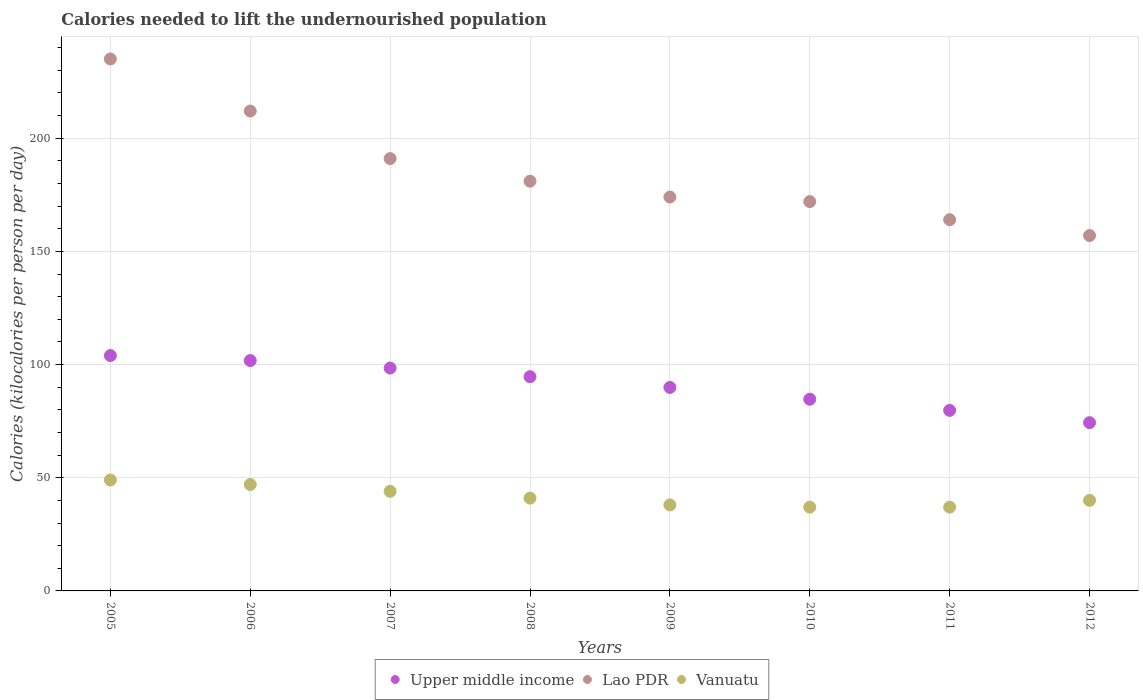How many different coloured dotlines are there?
Offer a terse response. 3. Is the number of dotlines equal to the number of legend labels?
Keep it short and to the point. Yes. What is the total calories needed to lift the undernourished population in Lao PDR in 2007?
Your answer should be compact. 191. Across all years, what is the maximum total calories needed to lift the undernourished population in Lao PDR?
Provide a succinct answer. 235. Across all years, what is the minimum total calories needed to lift the undernourished population in Lao PDR?
Offer a very short reply. 157. In which year was the total calories needed to lift the undernourished population in Vanuatu maximum?
Provide a short and direct response. 2005. What is the total total calories needed to lift the undernourished population in Vanuatu in the graph?
Ensure brevity in your answer.  333. What is the difference between the total calories needed to lift the undernourished population in Vanuatu in 2005 and that in 2007?
Ensure brevity in your answer.  5. What is the difference between the total calories needed to lift the undernourished population in Lao PDR in 2011 and the total calories needed to lift the undernourished population in Vanuatu in 2009?
Your answer should be very brief. 126. What is the average total calories needed to lift the undernourished population in Lao PDR per year?
Provide a succinct answer. 185.75. In the year 2007, what is the difference between the total calories needed to lift the undernourished population in Upper middle income and total calories needed to lift the undernourished population in Lao PDR?
Keep it short and to the point. -92.55. In how many years, is the total calories needed to lift the undernourished population in Upper middle income greater than 80 kilocalories?
Provide a short and direct response. 6. What is the ratio of the total calories needed to lift the undernourished population in Vanuatu in 2006 to that in 2007?
Provide a succinct answer. 1.07. What is the difference between the highest and the second highest total calories needed to lift the undernourished population in Upper middle income?
Give a very brief answer. 2.21. What is the difference between the highest and the lowest total calories needed to lift the undernourished population in Lao PDR?
Offer a very short reply. 78. In how many years, is the total calories needed to lift the undernourished population in Vanuatu greater than the average total calories needed to lift the undernourished population in Vanuatu taken over all years?
Provide a short and direct response. 3. Is it the case that in every year, the sum of the total calories needed to lift the undernourished population in Vanuatu and total calories needed to lift the undernourished population in Lao PDR  is greater than the total calories needed to lift the undernourished population in Upper middle income?
Make the answer very short. Yes. Is the total calories needed to lift the undernourished population in Vanuatu strictly greater than the total calories needed to lift the undernourished population in Upper middle income over the years?
Offer a very short reply. No. Is the total calories needed to lift the undernourished population in Upper middle income strictly less than the total calories needed to lift the undernourished population in Lao PDR over the years?
Make the answer very short. Yes. Does the graph contain grids?
Give a very brief answer. Yes. How many legend labels are there?
Your answer should be very brief. 3. How are the legend labels stacked?
Offer a terse response. Horizontal. What is the title of the graph?
Your answer should be compact. Calories needed to lift the undernourished population. Does "Greece" appear as one of the legend labels in the graph?
Offer a very short reply. No. What is the label or title of the X-axis?
Ensure brevity in your answer.  Years. What is the label or title of the Y-axis?
Ensure brevity in your answer.  Calories (kilocalories per person per day). What is the Calories (kilocalories per person per day) of Upper middle income in 2005?
Offer a terse response. 103.98. What is the Calories (kilocalories per person per day) in Lao PDR in 2005?
Provide a succinct answer. 235. What is the Calories (kilocalories per person per day) of Upper middle income in 2006?
Your answer should be compact. 101.77. What is the Calories (kilocalories per person per day) in Lao PDR in 2006?
Provide a short and direct response. 212. What is the Calories (kilocalories per person per day) of Vanuatu in 2006?
Your response must be concise. 47. What is the Calories (kilocalories per person per day) of Upper middle income in 2007?
Keep it short and to the point. 98.45. What is the Calories (kilocalories per person per day) of Lao PDR in 2007?
Your answer should be compact. 191. What is the Calories (kilocalories per person per day) in Upper middle income in 2008?
Give a very brief answer. 94.65. What is the Calories (kilocalories per person per day) of Lao PDR in 2008?
Make the answer very short. 181. What is the Calories (kilocalories per person per day) in Upper middle income in 2009?
Your response must be concise. 89.9. What is the Calories (kilocalories per person per day) of Lao PDR in 2009?
Give a very brief answer. 174. What is the Calories (kilocalories per person per day) of Upper middle income in 2010?
Your answer should be very brief. 84.69. What is the Calories (kilocalories per person per day) of Lao PDR in 2010?
Make the answer very short. 172. What is the Calories (kilocalories per person per day) in Vanuatu in 2010?
Give a very brief answer. 37. What is the Calories (kilocalories per person per day) in Upper middle income in 2011?
Offer a very short reply. 79.75. What is the Calories (kilocalories per person per day) of Lao PDR in 2011?
Your response must be concise. 164. What is the Calories (kilocalories per person per day) in Upper middle income in 2012?
Provide a short and direct response. 74.34. What is the Calories (kilocalories per person per day) in Lao PDR in 2012?
Make the answer very short. 157. Across all years, what is the maximum Calories (kilocalories per person per day) of Upper middle income?
Your response must be concise. 103.98. Across all years, what is the maximum Calories (kilocalories per person per day) in Lao PDR?
Keep it short and to the point. 235. Across all years, what is the maximum Calories (kilocalories per person per day) in Vanuatu?
Give a very brief answer. 49. Across all years, what is the minimum Calories (kilocalories per person per day) of Upper middle income?
Provide a succinct answer. 74.34. Across all years, what is the minimum Calories (kilocalories per person per day) of Lao PDR?
Make the answer very short. 157. What is the total Calories (kilocalories per person per day) in Upper middle income in the graph?
Give a very brief answer. 727.54. What is the total Calories (kilocalories per person per day) of Lao PDR in the graph?
Keep it short and to the point. 1486. What is the total Calories (kilocalories per person per day) of Vanuatu in the graph?
Your response must be concise. 333. What is the difference between the Calories (kilocalories per person per day) in Upper middle income in 2005 and that in 2006?
Make the answer very short. 2.21. What is the difference between the Calories (kilocalories per person per day) of Vanuatu in 2005 and that in 2006?
Ensure brevity in your answer.  2. What is the difference between the Calories (kilocalories per person per day) in Upper middle income in 2005 and that in 2007?
Your answer should be very brief. 5.53. What is the difference between the Calories (kilocalories per person per day) of Upper middle income in 2005 and that in 2008?
Offer a terse response. 9.33. What is the difference between the Calories (kilocalories per person per day) in Lao PDR in 2005 and that in 2008?
Provide a short and direct response. 54. What is the difference between the Calories (kilocalories per person per day) in Upper middle income in 2005 and that in 2009?
Your answer should be very brief. 14.08. What is the difference between the Calories (kilocalories per person per day) of Vanuatu in 2005 and that in 2009?
Your answer should be compact. 11. What is the difference between the Calories (kilocalories per person per day) in Upper middle income in 2005 and that in 2010?
Offer a terse response. 19.29. What is the difference between the Calories (kilocalories per person per day) in Lao PDR in 2005 and that in 2010?
Your answer should be compact. 63. What is the difference between the Calories (kilocalories per person per day) of Vanuatu in 2005 and that in 2010?
Provide a succinct answer. 12. What is the difference between the Calories (kilocalories per person per day) of Upper middle income in 2005 and that in 2011?
Make the answer very short. 24.23. What is the difference between the Calories (kilocalories per person per day) in Upper middle income in 2005 and that in 2012?
Make the answer very short. 29.64. What is the difference between the Calories (kilocalories per person per day) in Vanuatu in 2005 and that in 2012?
Provide a succinct answer. 9. What is the difference between the Calories (kilocalories per person per day) in Upper middle income in 2006 and that in 2007?
Your answer should be very brief. 3.32. What is the difference between the Calories (kilocalories per person per day) in Vanuatu in 2006 and that in 2007?
Keep it short and to the point. 3. What is the difference between the Calories (kilocalories per person per day) of Upper middle income in 2006 and that in 2008?
Ensure brevity in your answer.  7.12. What is the difference between the Calories (kilocalories per person per day) in Lao PDR in 2006 and that in 2008?
Your answer should be very brief. 31. What is the difference between the Calories (kilocalories per person per day) of Upper middle income in 2006 and that in 2009?
Your answer should be compact. 11.87. What is the difference between the Calories (kilocalories per person per day) of Lao PDR in 2006 and that in 2009?
Your answer should be very brief. 38. What is the difference between the Calories (kilocalories per person per day) in Upper middle income in 2006 and that in 2010?
Your answer should be compact. 17.08. What is the difference between the Calories (kilocalories per person per day) of Upper middle income in 2006 and that in 2011?
Your answer should be very brief. 22.02. What is the difference between the Calories (kilocalories per person per day) in Upper middle income in 2006 and that in 2012?
Ensure brevity in your answer.  27.44. What is the difference between the Calories (kilocalories per person per day) in Lao PDR in 2006 and that in 2012?
Your answer should be very brief. 55. What is the difference between the Calories (kilocalories per person per day) in Upper middle income in 2007 and that in 2008?
Provide a succinct answer. 3.8. What is the difference between the Calories (kilocalories per person per day) in Lao PDR in 2007 and that in 2008?
Provide a short and direct response. 10. What is the difference between the Calories (kilocalories per person per day) of Upper middle income in 2007 and that in 2009?
Ensure brevity in your answer.  8.56. What is the difference between the Calories (kilocalories per person per day) in Lao PDR in 2007 and that in 2009?
Offer a terse response. 17. What is the difference between the Calories (kilocalories per person per day) in Upper middle income in 2007 and that in 2010?
Your answer should be compact. 13.76. What is the difference between the Calories (kilocalories per person per day) in Lao PDR in 2007 and that in 2010?
Your response must be concise. 19. What is the difference between the Calories (kilocalories per person per day) in Upper middle income in 2007 and that in 2011?
Make the answer very short. 18.7. What is the difference between the Calories (kilocalories per person per day) in Vanuatu in 2007 and that in 2011?
Ensure brevity in your answer.  7. What is the difference between the Calories (kilocalories per person per day) in Upper middle income in 2007 and that in 2012?
Give a very brief answer. 24.12. What is the difference between the Calories (kilocalories per person per day) in Lao PDR in 2007 and that in 2012?
Provide a short and direct response. 34. What is the difference between the Calories (kilocalories per person per day) in Upper middle income in 2008 and that in 2009?
Ensure brevity in your answer.  4.75. What is the difference between the Calories (kilocalories per person per day) in Lao PDR in 2008 and that in 2009?
Offer a very short reply. 7. What is the difference between the Calories (kilocalories per person per day) in Vanuatu in 2008 and that in 2009?
Give a very brief answer. 3. What is the difference between the Calories (kilocalories per person per day) of Upper middle income in 2008 and that in 2010?
Give a very brief answer. 9.96. What is the difference between the Calories (kilocalories per person per day) in Upper middle income in 2008 and that in 2011?
Ensure brevity in your answer.  14.9. What is the difference between the Calories (kilocalories per person per day) of Vanuatu in 2008 and that in 2011?
Make the answer very short. 4. What is the difference between the Calories (kilocalories per person per day) of Upper middle income in 2008 and that in 2012?
Your answer should be compact. 20.31. What is the difference between the Calories (kilocalories per person per day) in Vanuatu in 2008 and that in 2012?
Offer a terse response. 1. What is the difference between the Calories (kilocalories per person per day) in Upper middle income in 2009 and that in 2010?
Offer a very short reply. 5.21. What is the difference between the Calories (kilocalories per person per day) in Lao PDR in 2009 and that in 2010?
Make the answer very short. 2. What is the difference between the Calories (kilocalories per person per day) in Upper middle income in 2009 and that in 2011?
Offer a very short reply. 10.15. What is the difference between the Calories (kilocalories per person per day) of Lao PDR in 2009 and that in 2011?
Your response must be concise. 10. What is the difference between the Calories (kilocalories per person per day) in Upper middle income in 2009 and that in 2012?
Ensure brevity in your answer.  15.56. What is the difference between the Calories (kilocalories per person per day) of Upper middle income in 2010 and that in 2011?
Provide a succinct answer. 4.94. What is the difference between the Calories (kilocalories per person per day) of Vanuatu in 2010 and that in 2011?
Keep it short and to the point. 0. What is the difference between the Calories (kilocalories per person per day) of Upper middle income in 2010 and that in 2012?
Offer a terse response. 10.35. What is the difference between the Calories (kilocalories per person per day) in Upper middle income in 2011 and that in 2012?
Your answer should be compact. 5.41. What is the difference between the Calories (kilocalories per person per day) in Vanuatu in 2011 and that in 2012?
Make the answer very short. -3. What is the difference between the Calories (kilocalories per person per day) of Upper middle income in 2005 and the Calories (kilocalories per person per day) of Lao PDR in 2006?
Give a very brief answer. -108.02. What is the difference between the Calories (kilocalories per person per day) of Upper middle income in 2005 and the Calories (kilocalories per person per day) of Vanuatu in 2006?
Your response must be concise. 56.98. What is the difference between the Calories (kilocalories per person per day) of Lao PDR in 2005 and the Calories (kilocalories per person per day) of Vanuatu in 2006?
Your answer should be very brief. 188. What is the difference between the Calories (kilocalories per person per day) of Upper middle income in 2005 and the Calories (kilocalories per person per day) of Lao PDR in 2007?
Offer a very short reply. -87.02. What is the difference between the Calories (kilocalories per person per day) in Upper middle income in 2005 and the Calories (kilocalories per person per day) in Vanuatu in 2007?
Ensure brevity in your answer.  59.98. What is the difference between the Calories (kilocalories per person per day) of Lao PDR in 2005 and the Calories (kilocalories per person per day) of Vanuatu in 2007?
Your response must be concise. 191. What is the difference between the Calories (kilocalories per person per day) of Upper middle income in 2005 and the Calories (kilocalories per person per day) of Lao PDR in 2008?
Your answer should be very brief. -77.02. What is the difference between the Calories (kilocalories per person per day) in Upper middle income in 2005 and the Calories (kilocalories per person per day) in Vanuatu in 2008?
Offer a terse response. 62.98. What is the difference between the Calories (kilocalories per person per day) of Lao PDR in 2005 and the Calories (kilocalories per person per day) of Vanuatu in 2008?
Give a very brief answer. 194. What is the difference between the Calories (kilocalories per person per day) in Upper middle income in 2005 and the Calories (kilocalories per person per day) in Lao PDR in 2009?
Ensure brevity in your answer.  -70.02. What is the difference between the Calories (kilocalories per person per day) in Upper middle income in 2005 and the Calories (kilocalories per person per day) in Vanuatu in 2009?
Your response must be concise. 65.98. What is the difference between the Calories (kilocalories per person per day) of Lao PDR in 2005 and the Calories (kilocalories per person per day) of Vanuatu in 2009?
Offer a very short reply. 197. What is the difference between the Calories (kilocalories per person per day) of Upper middle income in 2005 and the Calories (kilocalories per person per day) of Lao PDR in 2010?
Your answer should be very brief. -68.02. What is the difference between the Calories (kilocalories per person per day) of Upper middle income in 2005 and the Calories (kilocalories per person per day) of Vanuatu in 2010?
Ensure brevity in your answer.  66.98. What is the difference between the Calories (kilocalories per person per day) of Lao PDR in 2005 and the Calories (kilocalories per person per day) of Vanuatu in 2010?
Keep it short and to the point. 198. What is the difference between the Calories (kilocalories per person per day) of Upper middle income in 2005 and the Calories (kilocalories per person per day) of Lao PDR in 2011?
Ensure brevity in your answer.  -60.02. What is the difference between the Calories (kilocalories per person per day) of Upper middle income in 2005 and the Calories (kilocalories per person per day) of Vanuatu in 2011?
Your answer should be compact. 66.98. What is the difference between the Calories (kilocalories per person per day) of Lao PDR in 2005 and the Calories (kilocalories per person per day) of Vanuatu in 2011?
Your response must be concise. 198. What is the difference between the Calories (kilocalories per person per day) in Upper middle income in 2005 and the Calories (kilocalories per person per day) in Lao PDR in 2012?
Provide a succinct answer. -53.02. What is the difference between the Calories (kilocalories per person per day) in Upper middle income in 2005 and the Calories (kilocalories per person per day) in Vanuatu in 2012?
Make the answer very short. 63.98. What is the difference between the Calories (kilocalories per person per day) in Lao PDR in 2005 and the Calories (kilocalories per person per day) in Vanuatu in 2012?
Keep it short and to the point. 195. What is the difference between the Calories (kilocalories per person per day) of Upper middle income in 2006 and the Calories (kilocalories per person per day) of Lao PDR in 2007?
Your answer should be compact. -89.23. What is the difference between the Calories (kilocalories per person per day) of Upper middle income in 2006 and the Calories (kilocalories per person per day) of Vanuatu in 2007?
Provide a short and direct response. 57.77. What is the difference between the Calories (kilocalories per person per day) of Lao PDR in 2006 and the Calories (kilocalories per person per day) of Vanuatu in 2007?
Your response must be concise. 168. What is the difference between the Calories (kilocalories per person per day) in Upper middle income in 2006 and the Calories (kilocalories per person per day) in Lao PDR in 2008?
Your answer should be compact. -79.23. What is the difference between the Calories (kilocalories per person per day) of Upper middle income in 2006 and the Calories (kilocalories per person per day) of Vanuatu in 2008?
Make the answer very short. 60.77. What is the difference between the Calories (kilocalories per person per day) in Lao PDR in 2006 and the Calories (kilocalories per person per day) in Vanuatu in 2008?
Provide a short and direct response. 171. What is the difference between the Calories (kilocalories per person per day) of Upper middle income in 2006 and the Calories (kilocalories per person per day) of Lao PDR in 2009?
Keep it short and to the point. -72.23. What is the difference between the Calories (kilocalories per person per day) in Upper middle income in 2006 and the Calories (kilocalories per person per day) in Vanuatu in 2009?
Ensure brevity in your answer.  63.77. What is the difference between the Calories (kilocalories per person per day) of Lao PDR in 2006 and the Calories (kilocalories per person per day) of Vanuatu in 2009?
Your response must be concise. 174. What is the difference between the Calories (kilocalories per person per day) of Upper middle income in 2006 and the Calories (kilocalories per person per day) of Lao PDR in 2010?
Offer a terse response. -70.23. What is the difference between the Calories (kilocalories per person per day) of Upper middle income in 2006 and the Calories (kilocalories per person per day) of Vanuatu in 2010?
Offer a very short reply. 64.77. What is the difference between the Calories (kilocalories per person per day) in Lao PDR in 2006 and the Calories (kilocalories per person per day) in Vanuatu in 2010?
Your answer should be very brief. 175. What is the difference between the Calories (kilocalories per person per day) in Upper middle income in 2006 and the Calories (kilocalories per person per day) in Lao PDR in 2011?
Your answer should be very brief. -62.23. What is the difference between the Calories (kilocalories per person per day) in Upper middle income in 2006 and the Calories (kilocalories per person per day) in Vanuatu in 2011?
Provide a succinct answer. 64.77. What is the difference between the Calories (kilocalories per person per day) in Lao PDR in 2006 and the Calories (kilocalories per person per day) in Vanuatu in 2011?
Provide a succinct answer. 175. What is the difference between the Calories (kilocalories per person per day) of Upper middle income in 2006 and the Calories (kilocalories per person per day) of Lao PDR in 2012?
Your response must be concise. -55.23. What is the difference between the Calories (kilocalories per person per day) of Upper middle income in 2006 and the Calories (kilocalories per person per day) of Vanuatu in 2012?
Your answer should be compact. 61.77. What is the difference between the Calories (kilocalories per person per day) of Lao PDR in 2006 and the Calories (kilocalories per person per day) of Vanuatu in 2012?
Your response must be concise. 172. What is the difference between the Calories (kilocalories per person per day) of Upper middle income in 2007 and the Calories (kilocalories per person per day) of Lao PDR in 2008?
Give a very brief answer. -82.55. What is the difference between the Calories (kilocalories per person per day) in Upper middle income in 2007 and the Calories (kilocalories per person per day) in Vanuatu in 2008?
Your answer should be very brief. 57.45. What is the difference between the Calories (kilocalories per person per day) in Lao PDR in 2007 and the Calories (kilocalories per person per day) in Vanuatu in 2008?
Make the answer very short. 150. What is the difference between the Calories (kilocalories per person per day) in Upper middle income in 2007 and the Calories (kilocalories per person per day) in Lao PDR in 2009?
Ensure brevity in your answer.  -75.55. What is the difference between the Calories (kilocalories per person per day) in Upper middle income in 2007 and the Calories (kilocalories per person per day) in Vanuatu in 2009?
Provide a succinct answer. 60.45. What is the difference between the Calories (kilocalories per person per day) in Lao PDR in 2007 and the Calories (kilocalories per person per day) in Vanuatu in 2009?
Make the answer very short. 153. What is the difference between the Calories (kilocalories per person per day) of Upper middle income in 2007 and the Calories (kilocalories per person per day) of Lao PDR in 2010?
Ensure brevity in your answer.  -73.55. What is the difference between the Calories (kilocalories per person per day) of Upper middle income in 2007 and the Calories (kilocalories per person per day) of Vanuatu in 2010?
Make the answer very short. 61.45. What is the difference between the Calories (kilocalories per person per day) of Lao PDR in 2007 and the Calories (kilocalories per person per day) of Vanuatu in 2010?
Your answer should be very brief. 154. What is the difference between the Calories (kilocalories per person per day) of Upper middle income in 2007 and the Calories (kilocalories per person per day) of Lao PDR in 2011?
Provide a short and direct response. -65.55. What is the difference between the Calories (kilocalories per person per day) in Upper middle income in 2007 and the Calories (kilocalories per person per day) in Vanuatu in 2011?
Your answer should be very brief. 61.45. What is the difference between the Calories (kilocalories per person per day) of Lao PDR in 2007 and the Calories (kilocalories per person per day) of Vanuatu in 2011?
Give a very brief answer. 154. What is the difference between the Calories (kilocalories per person per day) in Upper middle income in 2007 and the Calories (kilocalories per person per day) in Lao PDR in 2012?
Ensure brevity in your answer.  -58.55. What is the difference between the Calories (kilocalories per person per day) of Upper middle income in 2007 and the Calories (kilocalories per person per day) of Vanuatu in 2012?
Offer a terse response. 58.45. What is the difference between the Calories (kilocalories per person per day) in Lao PDR in 2007 and the Calories (kilocalories per person per day) in Vanuatu in 2012?
Keep it short and to the point. 151. What is the difference between the Calories (kilocalories per person per day) of Upper middle income in 2008 and the Calories (kilocalories per person per day) of Lao PDR in 2009?
Ensure brevity in your answer.  -79.35. What is the difference between the Calories (kilocalories per person per day) of Upper middle income in 2008 and the Calories (kilocalories per person per day) of Vanuatu in 2009?
Your answer should be very brief. 56.65. What is the difference between the Calories (kilocalories per person per day) of Lao PDR in 2008 and the Calories (kilocalories per person per day) of Vanuatu in 2009?
Ensure brevity in your answer.  143. What is the difference between the Calories (kilocalories per person per day) of Upper middle income in 2008 and the Calories (kilocalories per person per day) of Lao PDR in 2010?
Provide a short and direct response. -77.35. What is the difference between the Calories (kilocalories per person per day) in Upper middle income in 2008 and the Calories (kilocalories per person per day) in Vanuatu in 2010?
Provide a succinct answer. 57.65. What is the difference between the Calories (kilocalories per person per day) in Lao PDR in 2008 and the Calories (kilocalories per person per day) in Vanuatu in 2010?
Give a very brief answer. 144. What is the difference between the Calories (kilocalories per person per day) of Upper middle income in 2008 and the Calories (kilocalories per person per day) of Lao PDR in 2011?
Your response must be concise. -69.35. What is the difference between the Calories (kilocalories per person per day) of Upper middle income in 2008 and the Calories (kilocalories per person per day) of Vanuatu in 2011?
Offer a very short reply. 57.65. What is the difference between the Calories (kilocalories per person per day) of Lao PDR in 2008 and the Calories (kilocalories per person per day) of Vanuatu in 2011?
Keep it short and to the point. 144. What is the difference between the Calories (kilocalories per person per day) in Upper middle income in 2008 and the Calories (kilocalories per person per day) in Lao PDR in 2012?
Your response must be concise. -62.35. What is the difference between the Calories (kilocalories per person per day) of Upper middle income in 2008 and the Calories (kilocalories per person per day) of Vanuatu in 2012?
Your answer should be compact. 54.65. What is the difference between the Calories (kilocalories per person per day) in Lao PDR in 2008 and the Calories (kilocalories per person per day) in Vanuatu in 2012?
Offer a very short reply. 141. What is the difference between the Calories (kilocalories per person per day) in Upper middle income in 2009 and the Calories (kilocalories per person per day) in Lao PDR in 2010?
Your answer should be very brief. -82.1. What is the difference between the Calories (kilocalories per person per day) in Upper middle income in 2009 and the Calories (kilocalories per person per day) in Vanuatu in 2010?
Make the answer very short. 52.9. What is the difference between the Calories (kilocalories per person per day) in Lao PDR in 2009 and the Calories (kilocalories per person per day) in Vanuatu in 2010?
Your answer should be compact. 137. What is the difference between the Calories (kilocalories per person per day) in Upper middle income in 2009 and the Calories (kilocalories per person per day) in Lao PDR in 2011?
Ensure brevity in your answer.  -74.1. What is the difference between the Calories (kilocalories per person per day) in Upper middle income in 2009 and the Calories (kilocalories per person per day) in Vanuatu in 2011?
Ensure brevity in your answer.  52.9. What is the difference between the Calories (kilocalories per person per day) of Lao PDR in 2009 and the Calories (kilocalories per person per day) of Vanuatu in 2011?
Keep it short and to the point. 137. What is the difference between the Calories (kilocalories per person per day) in Upper middle income in 2009 and the Calories (kilocalories per person per day) in Lao PDR in 2012?
Offer a terse response. -67.1. What is the difference between the Calories (kilocalories per person per day) in Upper middle income in 2009 and the Calories (kilocalories per person per day) in Vanuatu in 2012?
Your answer should be compact. 49.9. What is the difference between the Calories (kilocalories per person per day) of Lao PDR in 2009 and the Calories (kilocalories per person per day) of Vanuatu in 2012?
Offer a terse response. 134. What is the difference between the Calories (kilocalories per person per day) of Upper middle income in 2010 and the Calories (kilocalories per person per day) of Lao PDR in 2011?
Your answer should be compact. -79.31. What is the difference between the Calories (kilocalories per person per day) of Upper middle income in 2010 and the Calories (kilocalories per person per day) of Vanuatu in 2011?
Ensure brevity in your answer.  47.69. What is the difference between the Calories (kilocalories per person per day) in Lao PDR in 2010 and the Calories (kilocalories per person per day) in Vanuatu in 2011?
Give a very brief answer. 135. What is the difference between the Calories (kilocalories per person per day) in Upper middle income in 2010 and the Calories (kilocalories per person per day) in Lao PDR in 2012?
Provide a short and direct response. -72.31. What is the difference between the Calories (kilocalories per person per day) of Upper middle income in 2010 and the Calories (kilocalories per person per day) of Vanuatu in 2012?
Provide a short and direct response. 44.69. What is the difference between the Calories (kilocalories per person per day) of Lao PDR in 2010 and the Calories (kilocalories per person per day) of Vanuatu in 2012?
Provide a short and direct response. 132. What is the difference between the Calories (kilocalories per person per day) of Upper middle income in 2011 and the Calories (kilocalories per person per day) of Lao PDR in 2012?
Make the answer very short. -77.25. What is the difference between the Calories (kilocalories per person per day) in Upper middle income in 2011 and the Calories (kilocalories per person per day) in Vanuatu in 2012?
Provide a short and direct response. 39.75. What is the difference between the Calories (kilocalories per person per day) in Lao PDR in 2011 and the Calories (kilocalories per person per day) in Vanuatu in 2012?
Provide a short and direct response. 124. What is the average Calories (kilocalories per person per day) in Upper middle income per year?
Ensure brevity in your answer.  90.94. What is the average Calories (kilocalories per person per day) of Lao PDR per year?
Provide a succinct answer. 185.75. What is the average Calories (kilocalories per person per day) of Vanuatu per year?
Keep it short and to the point. 41.62. In the year 2005, what is the difference between the Calories (kilocalories per person per day) of Upper middle income and Calories (kilocalories per person per day) of Lao PDR?
Your answer should be very brief. -131.02. In the year 2005, what is the difference between the Calories (kilocalories per person per day) of Upper middle income and Calories (kilocalories per person per day) of Vanuatu?
Make the answer very short. 54.98. In the year 2005, what is the difference between the Calories (kilocalories per person per day) in Lao PDR and Calories (kilocalories per person per day) in Vanuatu?
Offer a very short reply. 186. In the year 2006, what is the difference between the Calories (kilocalories per person per day) of Upper middle income and Calories (kilocalories per person per day) of Lao PDR?
Offer a very short reply. -110.23. In the year 2006, what is the difference between the Calories (kilocalories per person per day) in Upper middle income and Calories (kilocalories per person per day) in Vanuatu?
Make the answer very short. 54.77. In the year 2006, what is the difference between the Calories (kilocalories per person per day) in Lao PDR and Calories (kilocalories per person per day) in Vanuatu?
Give a very brief answer. 165. In the year 2007, what is the difference between the Calories (kilocalories per person per day) of Upper middle income and Calories (kilocalories per person per day) of Lao PDR?
Provide a short and direct response. -92.55. In the year 2007, what is the difference between the Calories (kilocalories per person per day) in Upper middle income and Calories (kilocalories per person per day) in Vanuatu?
Provide a short and direct response. 54.45. In the year 2007, what is the difference between the Calories (kilocalories per person per day) in Lao PDR and Calories (kilocalories per person per day) in Vanuatu?
Your answer should be very brief. 147. In the year 2008, what is the difference between the Calories (kilocalories per person per day) in Upper middle income and Calories (kilocalories per person per day) in Lao PDR?
Your answer should be very brief. -86.35. In the year 2008, what is the difference between the Calories (kilocalories per person per day) of Upper middle income and Calories (kilocalories per person per day) of Vanuatu?
Your answer should be very brief. 53.65. In the year 2008, what is the difference between the Calories (kilocalories per person per day) in Lao PDR and Calories (kilocalories per person per day) in Vanuatu?
Your answer should be compact. 140. In the year 2009, what is the difference between the Calories (kilocalories per person per day) in Upper middle income and Calories (kilocalories per person per day) in Lao PDR?
Your answer should be compact. -84.1. In the year 2009, what is the difference between the Calories (kilocalories per person per day) in Upper middle income and Calories (kilocalories per person per day) in Vanuatu?
Offer a very short reply. 51.9. In the year 2009, what is the difference between the Calories (kilocalories per person per day) in Lao PDR and Calories (kilocalories per person per day) in Vanuatu?
Ensure brevity in your answer.  136. In the year 2010, what is the difference between the Calories (kilocalories per person per day) in Upper middle income and Calories (kilocalories per person per day) in Lao PDR?
Keep it short and to the point. -87.31. In the year 2010, what is the difference between the Calories (kilocalories per person per day) in Upper middle income and Calories (kilocalories per person per day) in Vanuatu?
Give a very brief answer. 47.69. In the year 2010, what is the difference between the Calories (kilocalories per person per day) of Lao PDR and Calories (kilocalories per person per day) of Vanuatu?
Ensure brevity in your answer.  135. In the year 2011, what is the difference between the Calories (kilocalories per person per day) in Upper middle income and Calories (kilocalories per person per day) in Lao PDR?
Your answer should be compact. -84.25. In the year 2011, what is the difference between the Calories (kilocalories per person per day) in Upper middle income and Calories (kilocalories per person per day) in Vanuatu?
Offer a terse response. 42.75. In the year 2011, what is the difference between the Calories (kilocalories per person per day) in Lao PDR and Calories (kilocalories per person per day) in Vanuatu?
Your answer should be compact. 127. In the year 2012, what is the difference between the Calories (kilocalories per person per day) in Upper middle income and Calories (kilocalories per person per day) in Lao PDR?
Your answer should be compact. -82.66. In the year 2012, what is the difference between the Calories (kilocalories per person per day) of Upper middle income and Calories (kilocalories per person per day) of Vanuatu?
Make the answer very short. 34.34. In the year 2012, what is the difference between the Calories (kilocalories per person per day) in Lao PDR and Calories (kilocalories per person per day) in Vanuatu?
Offer a very short reply. 117. What is the ratio of the Calories (kilocalories per person per day) of Upper middle income in 2005 to that in 2006?
Your response must be concise. 1.02. What is the ratio of the Calories (kilocalories per person per day) in Lao PDR in 2005 to that in 2006?
Provide a short and direct response. 1.11. What is the ratio of the Calories (kilocalories per person per day) of Vanuatu in 2005 to that in 2006?
Offer a terse response. 1.04. What is the ratio of the Calories (kilocalories per person per day) of Upper middle income in 2005 to that in 2007?
Give a very brief answer. 1.06. What is the ratio of the Calories (kilocalories per person per day) of Lao PDR in 2005 to that in 2007?
Make the answer very short. 1.23. What is the ratio of the Calories (kilocalories per person per day) in Vanuatu in 2005 to that in 2007?
Ensure brevity in your answer.  1.11. What is the ratio of the Calories (kilocalories per person per day) in Upper middle income in 2005 to that in 2008?
Your answer should be very brief. 1.1. What is the ratio of the Calories (kilocalories per person per day) of Lao PDR in 2005 to that in 2008?
Offer a very short reply. 1.3. What is the ratio of the Calories (kilocalories per person per day) of Vanuatu in 2005 to that in 2008?
Provide a succinct answer. 1.2. What is the ratio of the Calories (kilocalories per person per day) in Upper middle income in 2005 to that in 2009?
Your answer should be compact. 1.16. What is the ratio of the Calories (kilocalories per person per day) in Lao PDR in 2005 to that in 2009?
Ensure brevity in your answer.  1.35. What is the ratio of the Calories (kilocalories per person per day) in Vanuatu in 2005 to that in 2009?
Your answer should be compact. 1.29. What is the ratio of the Calories (kilocalories per person per day) of Upper middle income in 2005 to that in 2010?
Keep it short and to the point. 1.23. What is the ratio of the Calories (kilocalories per person per day) of Lao PDR in 2005 to that in 2010?
Ensure brevity in your answer.  1.37. What is the ratio of the Calories (kilocalories per person per day) in Vanuatu in 2005 to that in 2010?
Give a very brief answer. 1.32. What is the ratio of the Calories (kilocalories per person per day) of Upper middle income in 2005 to that in 2011?
Provide a short and direct response. 1.3. What is the ratio of the Calories (kilocalories per person per day) of Lao PDR in 2005 to that in 2011?
Your answer should be very brief. 1.43. What is the ratio of the Calories (kilocalories per person per day) of Vanuatu in 2005 to that in 2011?
Make the answer very short. 1.32. What is the ratio of the Calories (kilocalories per person per day) of Upper middle income in 2005 to that in 2012?
Provide a succinct answer. 1.4. What is the ratio of the Calories (kilocalories per person per day) in Lao PDR in 2005 to that in 2012?
Keep it short and to the point. 1.5. What is the ratio of the Calories (kilocalories per person per day) of Vanuatu in 2005 to that in 2012?
Offer a terse response. 1.23. What is the ratio of the Calories (kilocalories per person per day) in Upper middle income in 2006 to that in 2007?
Ensure brevity in your answer.  1.03. What is the ratio of the Calories (kilocalories per person per day) of Lao PDR in 2006 to that in 2007?
Offer a terse response. 1.11. What is the ratio of the Calories (kilocalories per person per day) of Vanuatu in 2006 to that in 2007?
Your answer should be compact. 1.07. What is the ratio of the Calories (kilocalories per person per day) in Upper middle income in 2006 to that in 2008?
Your answer should be very brief. 1.08. What is the ratio of the Calories (kilocalories per person per day) in Lao PDR in 2006 to that in 2008?
Your answer should be compact. 1.17. What is the ratio of the Calories (kilocalories per person per day) in Vanuatu in 2006 to that in 2008?
Your response must be concise. 1.15. What is the ratio of the Calories (kilocalories per person per day) of Upper middle income in 2006 to that in 2009?
Your answer should be compact. 1.13. What is the ratio of the Calories (kilocalories per person per day) in Lao PDR in 2006 to that in 2009?
Your answer should be compact. 1.22. What is the ratio of the Calories (kilocalories per person per day) in Vanuatu in 2006 to that in 2009?
Offer a very short reply. 1.24. What is the ratio of the Calories (kilocalories per person per day) of Upper middle income in 2006 to that in 2010?
Your answer should be very brief. 1.2. What is the ratio of the Calories (kilocalories per person per day) of Lao PDR in 2006 to that in 2010?
Provide a succinct answer. 1.23. What is the ratio of the Calories (kilocalories per person per day) of Vanuatu in 2006 to that in 2010?
Make the answer very short. 1.27. What is the ratio of the Calories (kilocalories per person per day) in Upper middle income in 2006 to that in 2011?
Offer a terse response. 1.28. What is the ratio of the Calories (kilocalories per person per day) of Lao PDR in 2006 to that in 2011?
Make the answer very short. 1.29. What is the ratio of the Calories (kilocalories per person per day) in Vanuatu in 2006 to that in 2011?
Ensure brevity in your answer.  1.27. What is the ratio of the Calories (kilocalories per person per day) of Upper middle income in 2006 to that in 2012?
Provide a short and direct response. 1.37. What is the ratio of the Calories (kilocalories per person per day) in Lao PDR in 2006 to that in 2012?
Offer a terse response. 1.35. What is the ratio of the Calories (kilocalories per person per day) in Vanuatu in 2006 to that in 2012?
Offer a terse response. 1.18. What is the ratio of the Calories (kilocalories per person per day) in Upper middle income in 2007 to that in 2008?
Make the answer very short. 1.04. What is the ratio of the Calories (kilocalories per person per day) of Lao PDR in 2007 to that in 2008?
Provide a succinct answer. 1.06. What is the ratio of the Calories (kilocalories per person per day) of Vanuatu in 2007 to that in 2008?
Your answer should be very brief. 1.07. What is the ratio of the Calories (kilocalories per person per day) in Upper middle income in 2007 to that in 2009?
Give a very brief answer. 1.1. What is the ratio of the Calories (kilocalories per person per day) of Lao PDR in 2007 to that in 2009?
Your answer should be very brief. 1.1. What is the ratio of the Calories (kilocalories per person per day) of Vanuatu in 2007 to that in 2009?
Provide a short and direct response. 1.16. What is the ratio of the Calories (kilocalories per person per day) of Upper middle income in 2007 to that in 2010?
Make the answer very short. 1.16. What is the ratio of the Calories (kilocalories per person per day) of Lao PDR in 2007 to that in 2010?
Ensure brevity in your answer.  1.11. What is the ratio of the Calories (kilocalories per person per day) of Vanuatu in 2007 to that in 2010?
Provide a succinct answer. 1.19. What is the ratio of the Calories (kilocalories per person per day) in Upper middle income in 2007 to that in 2011?
Offer a terse response. 1.23. What is the ratio of the Calories (kilocalories per person per day) of Lao PDR in 2007 to that in 2011?
Make the answer very short. 1.16. What is the ratio of the Calories (kilocalories per person per day) in Vanuatu in 2007 to that in 2011?
Make the answer very short. 1.19. What is the ratio of the Calories (kilocalories per person per day) of Upper middle income in 2007 to that in 2012?
Your response must be concise. 1.32. What is the ratio of the Calories (kilocalories per person per day) of Lao PDR in 2007 to that in 2012?
Ensure brevity in your answer.  1.22. What is the ratio of the Calories (kilocalories per person per day) in Vanuatu in 2007 to that in 2012?
Provide a succinct answer. 1.1. What is the ratio of the Calories (kilocalories per person per day) of Upper middle income in 2008 to that in 2009?
Offer a terse response. 1.05. What is the ratio of the Calories (kilocalories per person per day) in Lao PDR in 2008 to that in 2009?
Provide a short and direct response. 1.04. What is the ratio of the Calories (kilocalories per person per day) in Vanuatu in 2008 to that in 2009?
Offer a very short reply. 1.08. What is the ratio of the Calories (kilocalories per person per day) in Upper middle income in 2008 to that in 2010?
Provide a short and direct response. 1.12. What is the ratio of the Calories (kilocalories per person per day) of Lao PDR in 2008 to that in 2010?
Your answer should be very brief. 1.05. What is the ratio of the Calories (kilocalories per person per day) of Vanuatu in 2008 to that in 2010?
Make the answer very short. 1.11. What is the ratio of the Calories (kilocalories per person per day) in Upper middle income in 2008 to that in 2011?
Your answer should be very brief. 1.19. What is the ratio of the Calories (kilocalories per person per day) in Lao PDR in 2008 to that in 2011?
Offer a terse response. 1.1. What is the ratio of the Calories (kilocalories per person per day) in Vanuatu in 2008 to that in 2011?
Provide a short and direct response. 1.11. What is the ratio of the Calories (kilocalories per person per day) in Upper middle income in 2008 to that in 2012?
Offer a terse response. 1.27. What is the ratio of the Calories (kilocalories per person per day) in Lao PDR in 2008 to that in 2012?
Your answer should be very brief. 1.15. What is the ratio of the Calories (kilocalories per person per day) of Vanuatu in 2008 to that in 2012?
Give a very brief answer. 1.02. What is the ratio of the Calories (kilocalories per person per day) of Upper middle income in 2009 to that in 2010?
Your answer should be compact. 1.06. What is the ratio of the Calories (kilocalories per person per day) of Lao PDR in 2009 to that in 2010?
Offer a very short reply. 1.01. What is the ratio of the Calories (kilocalories per person per day) in Upper middle income in 2009 to that in 2011?
Make the answer very short. 1.13. What is the ratio of the Calories (kilocalories per person per day) of Lao PDR in 2009 to that in 2011?
Your response must be concise. 1.06. What is the ratio of the Calories (kilocalories per person per day) in Upper middle income in 2009 to that in 2012?
Ensure brevity in your answer.  1.21. What is the ratio of the Calories (kilocalories per person per day) of Lao PDR in 2009 to that in 2012?
Provide a succinct answer. 1.11. What is the ratio of the Calories (kilocalories per person per day) in Vanuatu in 2009 to that in 2012?
Make the answer very short. 0.95. What is the ratio of the Calories (kilocalories per person per day) of Upper middle income in 2010 to that in 2011?
Offer a very short reply. 1.06. What is the ratio of the Calories (kilocalories per person per day) of Lao PDR in 2010 to that in 2011?
Provide a succinct answer. 1.05. What is the ratio of the Calories (kilocalories per person per day) in Vanuatu in 2010 to that in 2011?
Your answer should be very brief. 1. What is the ratio of the Calories (kilocalories per person per day) of Upper middle income in 2010 to that in 2012?
Your answer should be compact. 1.14. What is the ratio of the Calories (kilocalories per person per day) in Lao PDR in 2010 to that in 2012?
Your response must be concise. 1.1. What is the ratio of the Calories (kilocalories per person per day) in Vanuatu in 2010 to that in 2012?
Your answer should be compact. 0.93. What is the ratio of the Calories (kilocalories per person per day) in Upper middle income in 2011 to that in 2012?
Ensure brevity in your answer.  1.07. What is the ratio of the Calories (kilocalories per person per day) of Lao PDR in 2011 to that in 2012?
Your answer should be very brief. 1.04. What is the ratio of the Calories (kilocalories per person per day) in Vanuatu in 2011 to that in 2012?
Give a very brief answer. 0.93. What is the difference between the highest and the second highest Calories (kilocalories per person per day) of Upper middle income?
Give a very brief answer. 2.21. What is the difference between the highest and the second highest Calories (kilocalories per person per day) of Lao PDR?
Ensure brevity in your answer.  23. What is the difference between the highest and the lowest Calories (kilocalories per person per day) of Upper middle income?
Offer a very short reply. 29.64. What is the difference between the highest and the lowest Calories (kilocalories per person per day) of Vanuatu?
Offer a very short reply. 12. 